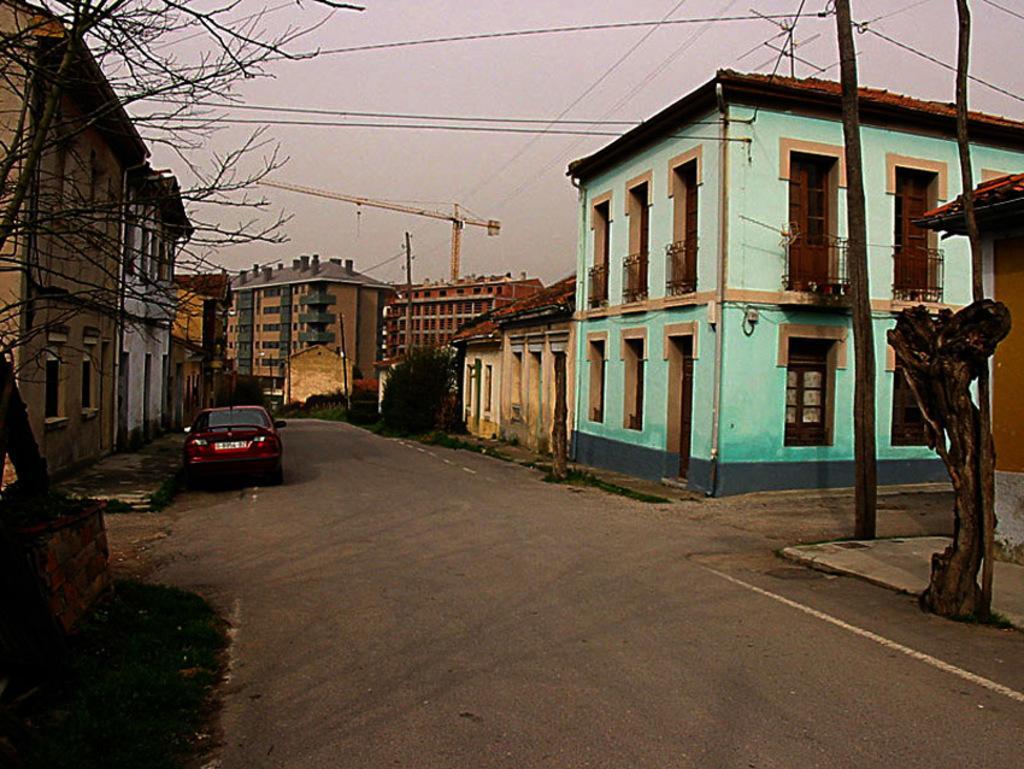In one or two sentences, can you explain what this image depicts? This image is clicked on the road. There is a car parked on the road. Beside the road there is a walk way. There are plants and tree trunks on the walkway. In the background there are buildings. To the left there is a tree. There is grass around the tree. At the top there is the sky. 